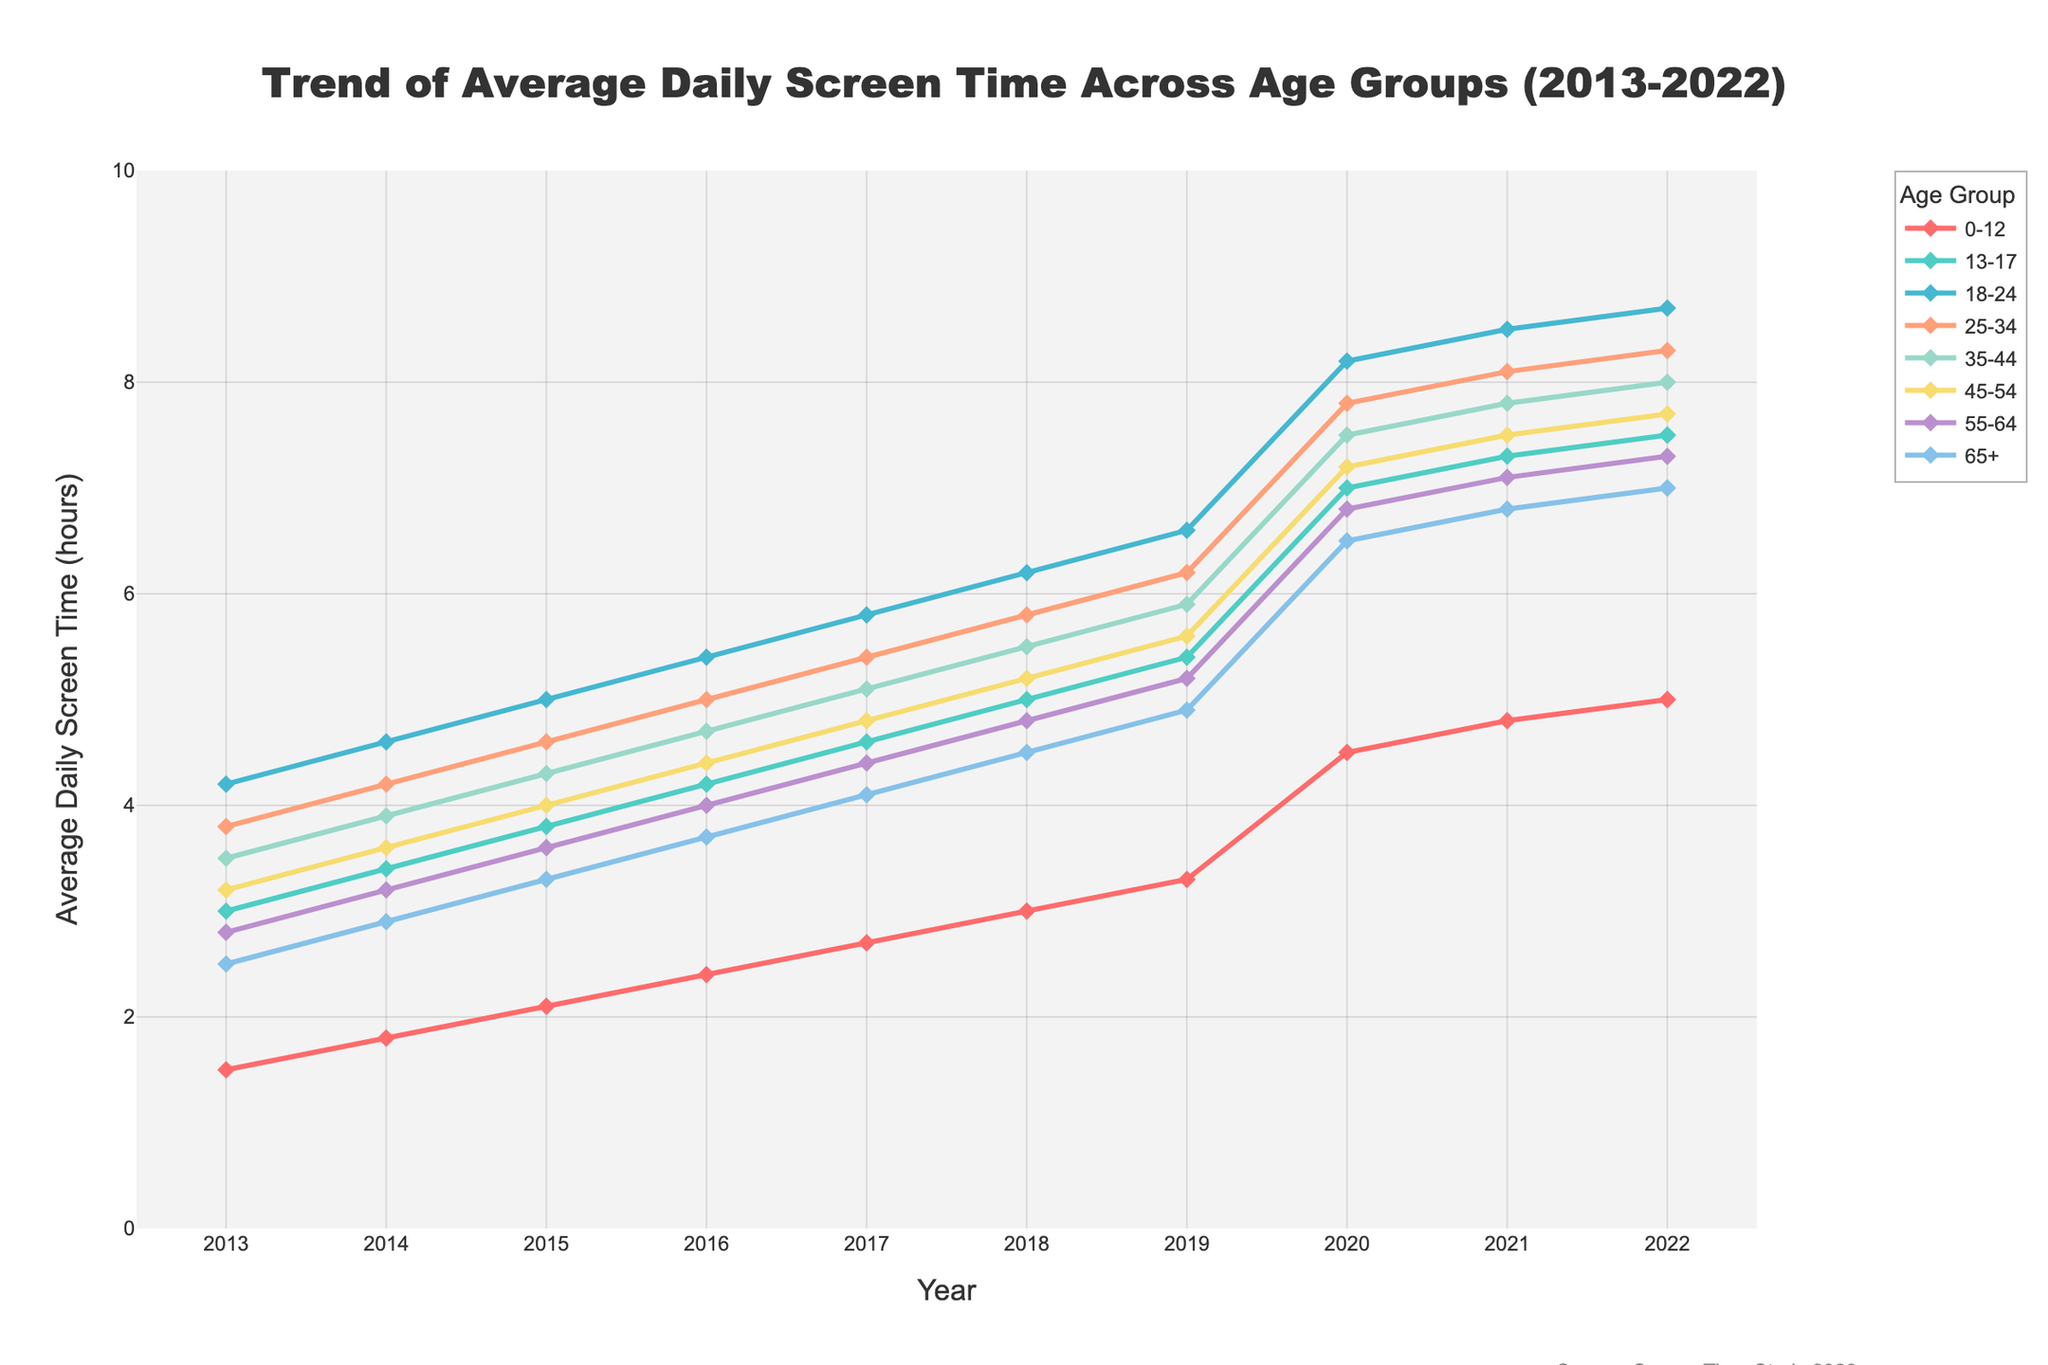Which age group had the highest average daily screen time in 2022? From the figure, by comparing the end points of all the lines representing different age groups for the year 2022, we can see that the group with the highest value is represented by the line for age group 18-24.
Answer: 18-24 What is the overall trend of screen time for the age group 0-12 from 2013 to 2022? The line representing the 0-12 age group shows a consistent upward trend from 1.5 hours in 2013 to 5.0 hours in 2022. There is a noticeable increase starting from 2019.
Answer: Increasing Which two age groups had the closest average daily screen time in 2017? From the figure, observe the values for each age group in the year 2017 and compare them: 0-12 (2.7), 13-17 (4.6), 18-24 (5.8), 25-34 (5.4), 35-44 (5.1), 45-54 (4.8), 55-64 (4.4), 65+ (4.1). The closest values are 35-44 (5.1) and 25-34 (5.4).
Answer: 35-44 and 25-34 How much did the average daily screen time for the age group 13-17 increase from 2013 to 2022? Subtract the value for 2013 from the value for 2022 for the age group 13-17: 7.5 - 3.0 = 4.5 hours.
Answer: 4.5 hours Did any age group experience a decrease in average daily screen time in any year between 2013 and 2022? By observing each line for noticeable drops at any given point, we see that all age groups show consistent increases and no year-to-year decrease.
Answer: No Which age group saw the sharpest increase in screen time between 2019 and 2020? Comparing the slopes of all the lines between the years 2019 and 2020, the sharpest increase is seen in the line for age group 0-12 (increase from 3.3 to 4.5).
Answer: 0-12 What is the difference in average daily screen time between the age groups 25-34 and 55-64 in 2020? Subtract the value for 55-64 from the value for 25-34 in the year 2020: 7.8 - 6.8 = 1.0 hour.
Answer: 1.0 hour Which age group consistently had a lower average daily screen time compared to the 18-24 age group across all years? By comparing the line for 18-24 with each of the other age groups over all years, the 0-12 age group consistently has lower values in each year.
Answer: 0-12 During which year did the average daily screen time for the 65+ age group reach or exceed 6 hours for the first time? Observing the line for the 65+ age group, it reaches 6 hours for the first time in 2020.
Answer: 2020 What is the average increase in screen time per year for the age group 45-54 from 2013 to 2022? Calculate the difference between 2022 and 2013 values and divide by the number of years (7.7 - 3.2 = 4.5; 4.5/9 = 0.5)
Answer: 0.5 hours/year 